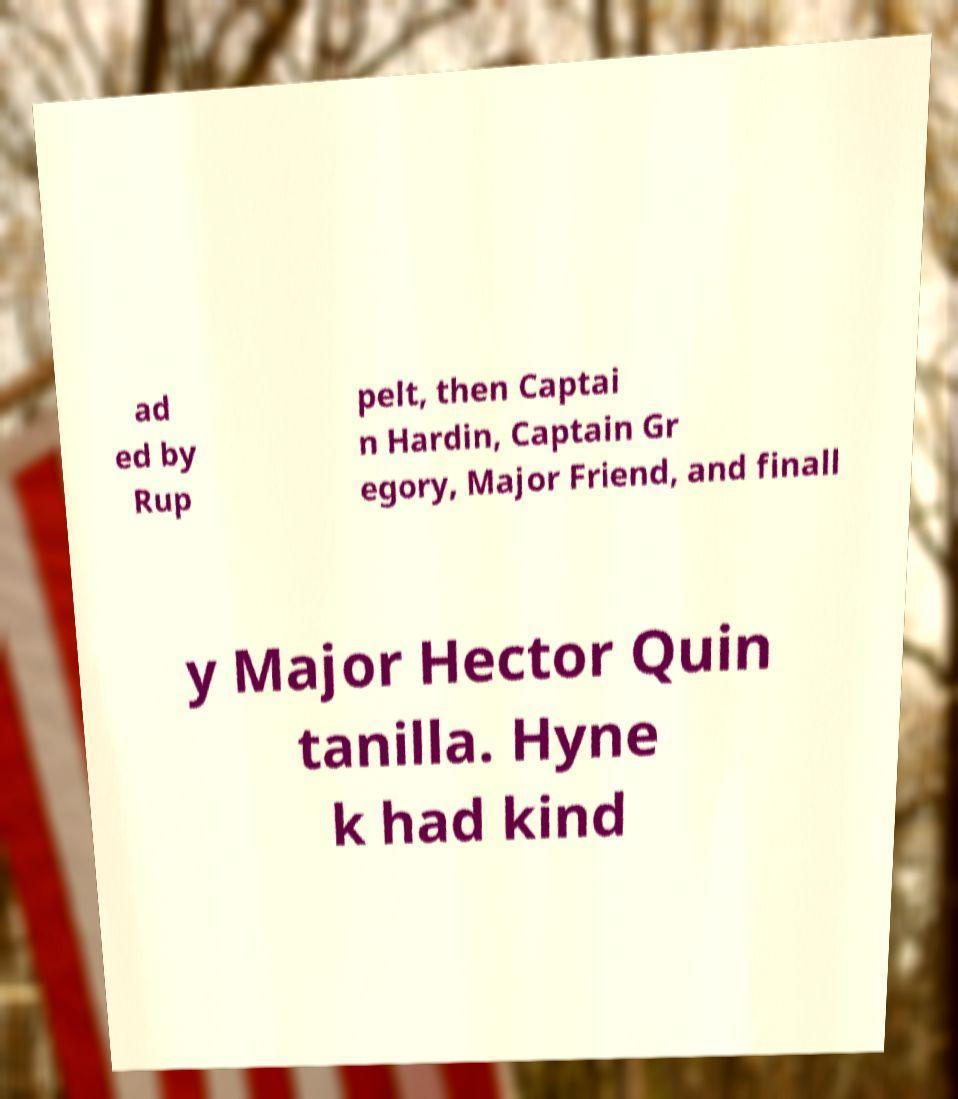Could you extract and type out the text from this image? ad ed by Rup pelt, then Captai n Hardin, Captain Gr egory, Major Friend, and finall y Major Hector Quin tanilla. Hyne k had kind 